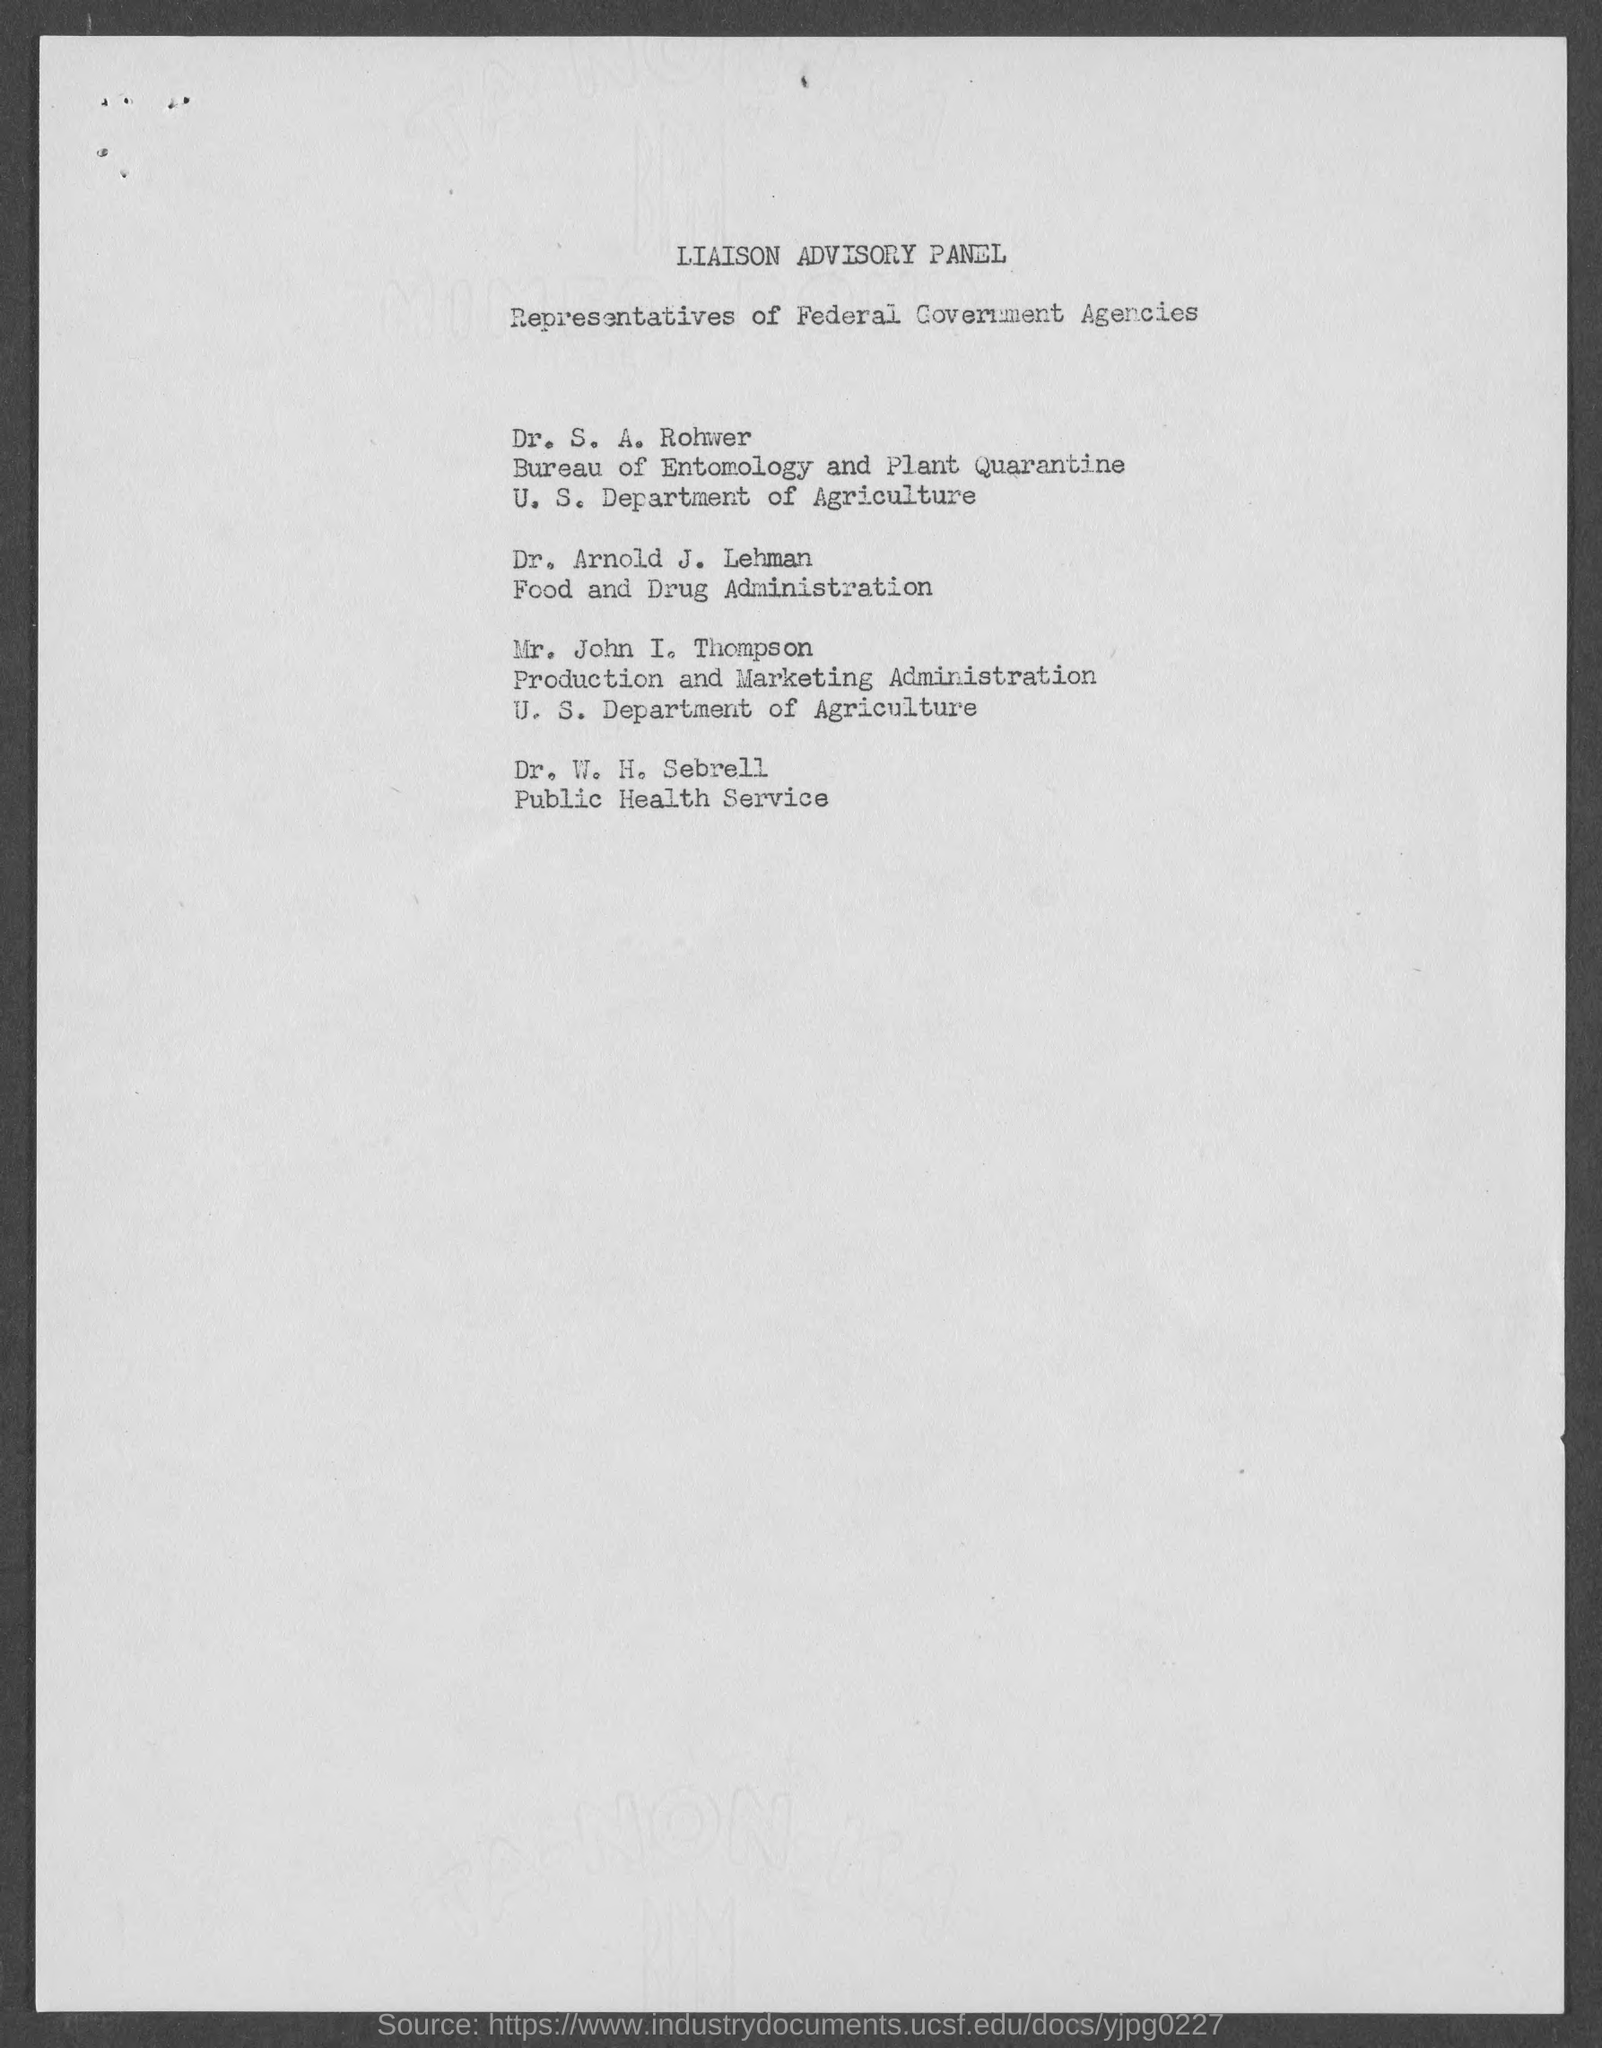What panel is it?
Offer a terse response. Liaison advisory panel. Who are the persons listed in the document?
Keep it short and to the point. Representatives of Federal Government Agencies. Who is from food and drug administration?
Ensure brevity in your answer.  Dr. Arnold J. Lehman. Who is from public health service?
Your response must be concise. Dr. W. H. Sebrell. 